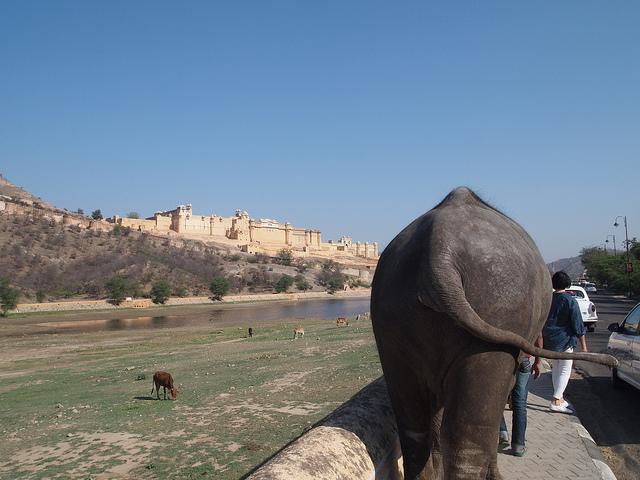How many people can be seen?
Give a very brief answer. 2. 